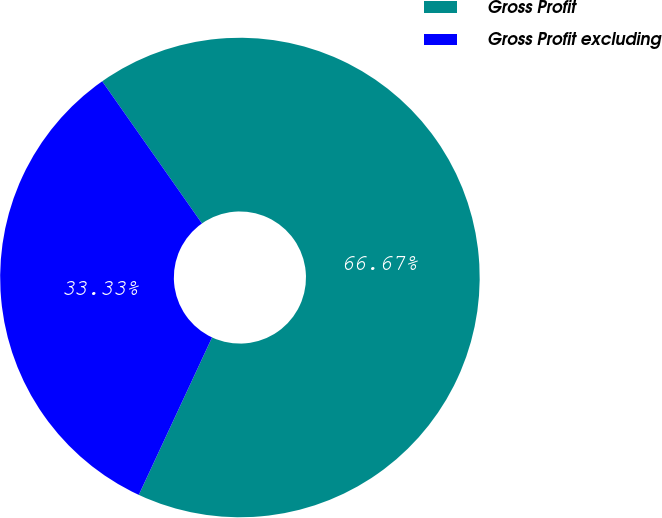Convert chart. <chart><loc_0><loc_0><loc_500><loc_500><pie_chart><fcel>Gross Profit<fcel>Gross Profit excluding<nl><fcel>66.67%<fcel>33.33%<nl></chart> 